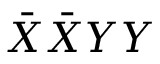<formula> <loc_0><loc_0><loc_500><loc_500>\bar { X } \bar { X } Y Y</formula> 